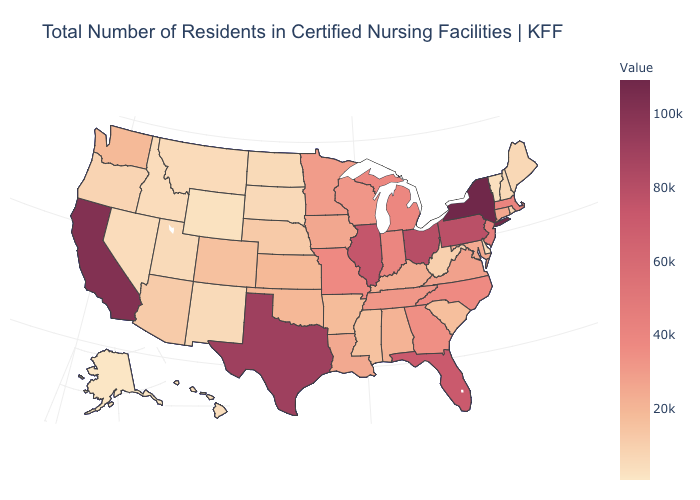Which states have the lowest value in the USA?
Answer briefly. Alaska. Does Alaska have the lowest value in the USA?
Answer briefly. Yes. Does the map have missing data?
Be succinct. No. Among the states that border Nevada , does California have the highest value?
Write a very short answer. Yes. Does Alaska have the lowest value in the USA?
Quick response, please. Yes. 